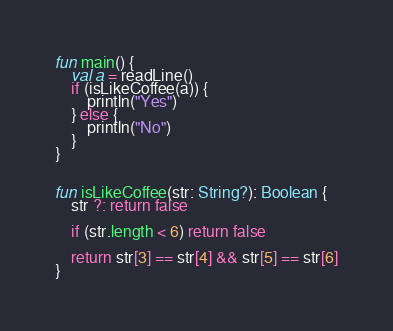<code> <loc_0><loc_0><loc_500><loc_500><_Kotlin_>fun main() {
    val a = readLine()
    if (isLikeCoffee(a)) {
        println("Yes")
    } else {
        println("No")
    }
}


fun isLikeCoffee(str: String?): Boolean {
    str ?: return false

    if (str.length < 6) return false

    return str[3] == str[4] && str[5] == str[6]
}
</code> 